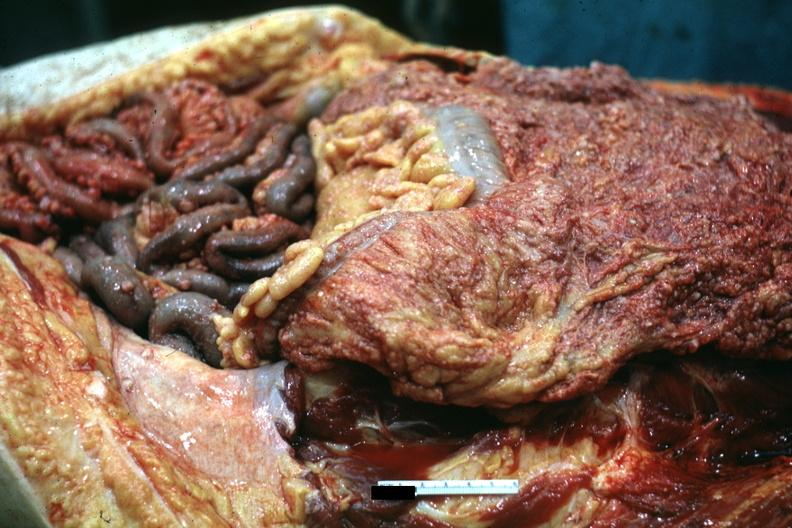where is this area in the body?
Answer the question using a single word or phrase. Abdomen 